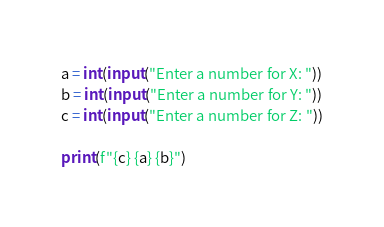<code> <loc_0><loc_0><loc_500><loc_500><_Python_>a = int(input("Enter a number for X: "))
b = int(input("Enter a number for Y: "))
c = int(input("Enter a number for Z: "))

print(f"{c} {a} {b}")
</code> 